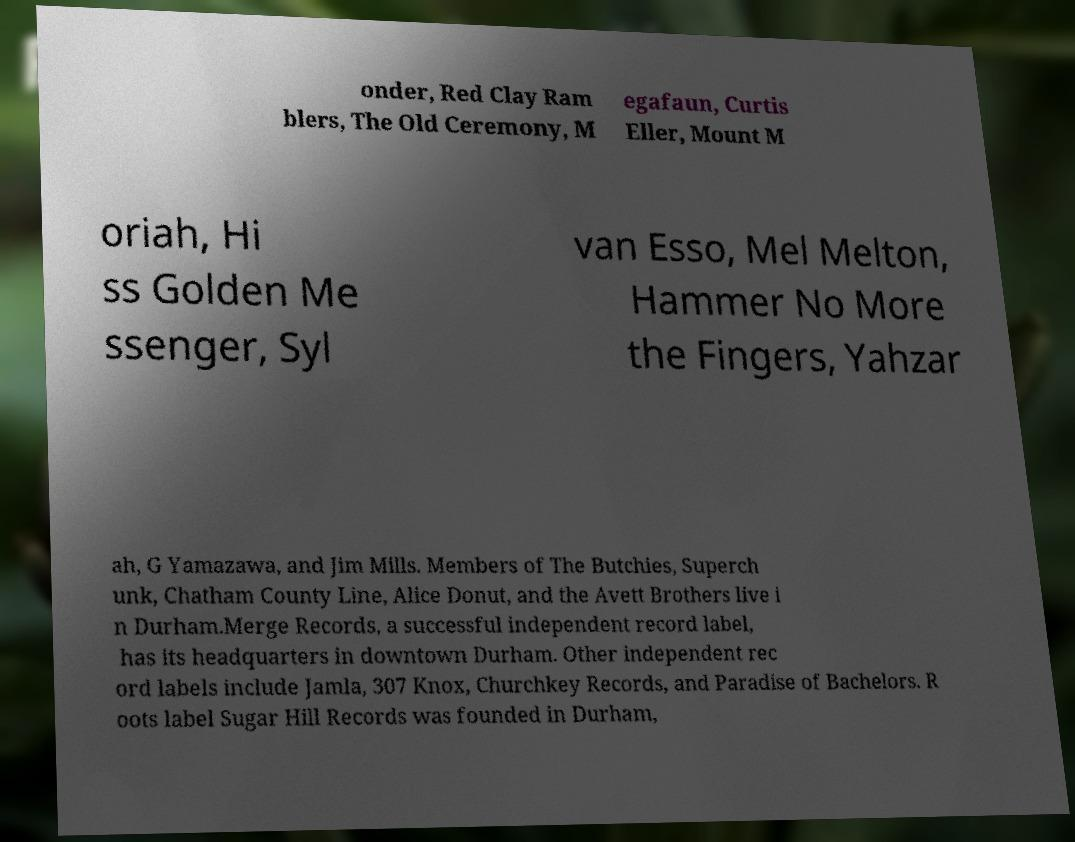There's text embedded in this image that I need extracted. Can you transcribe it verbatim? onder, Red Clay Ram blers, The Old Ceremony, M egafaun, Curtis Eller, Mount M oriah, Hi ss Golden Me ssenger, Syl van Esso, Mel Melton, Hammer No More the Fingers, Yahzar ah, G Yamazawa, and Jim Mills. Members of The Butchies, Superch unk, Chatham County Line, Alice Donut, and the Avett Brothers live i n Durham.Merge Records, a successful independent record label, has its headquarters in downtown Durham. Other independent rec ord labels include Jamla, 307 Knox, Churchkey Records, and Paradise of Bachelors. R oots label Sugar Hill Records was founded in Durham, 